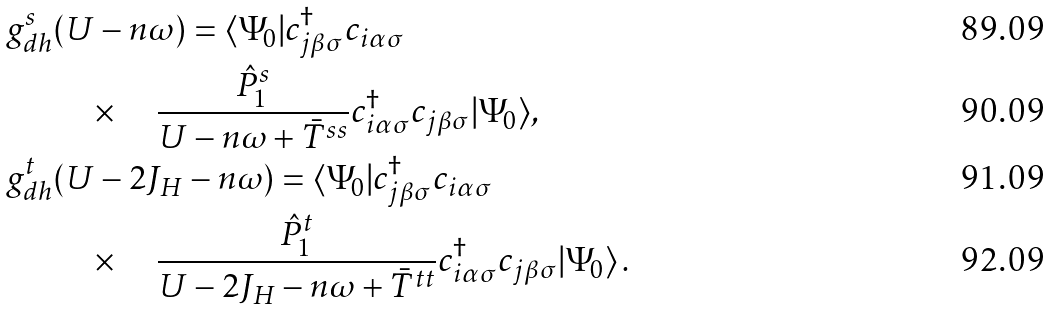<formula> <loc_0><loc_0><loc_500><loc_500>g _ { d h } ^ { s } & ( U - n \omega ) = \langle \Psi _ { 0 } | c _ { j \beta \sigma } ^ { \dagger } c _ { i \alpha \sigma } \\ & \quad \times \quad \frac { \hat { P } _ { 1 } ^ { s } } { U - n \omega + \bar { T } ^ { s s } } c _ { i \alpha \sigma } ^ { \dagger } c _ { j \beta \sigma } | \Psi _ { 0 } \rangle , \\ g _ { d h } ^ { t } & ( U - 2 J _ { H } - n \omega ) = \langle \Psi _ { 0 } | c _ { j \beta \sigma } ^ { \dagger } c _ { i \alpha \sigma } \\ & \quad \times \quad \frac { \hat { P } _ { 1 } ^ { t } } { U - 2 J _ { H } - n \omega + \bar { T } ^ { t t } } c _ { i \alpha \sigma } ^ { \dagger } c _ { j \beta \sigma } | \Psi _ { 0 } \rangle \, .</formula> 